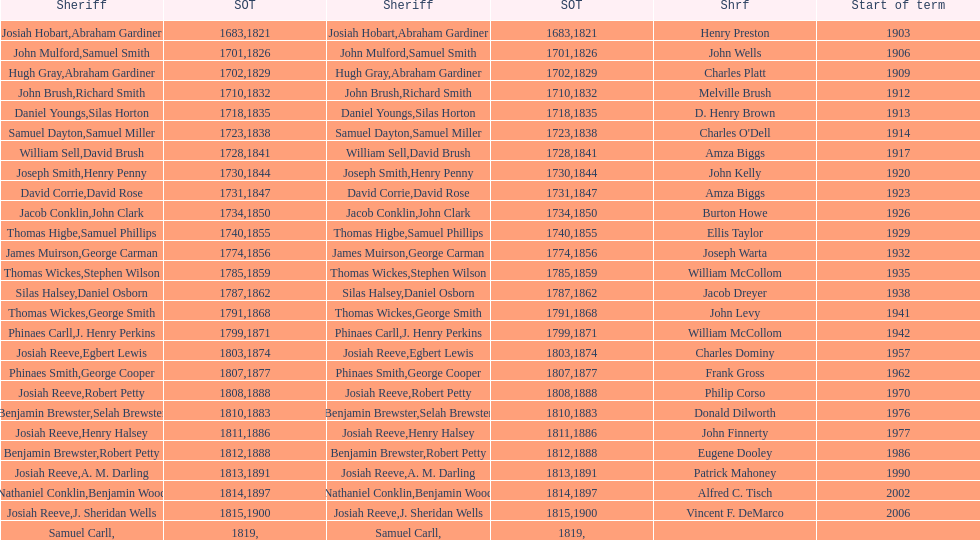When did the first sheriff's term start? 1683. 